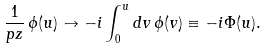Convert formula to latex. <formula><loc_0><loc_0><loc_500><loc_500>\frac { 1 } { p z } \, \phi ( u ) \to - i \int _ { 0 } ^ { u } d v \, \phi ( v ) \equiv - i \Phi ( u ) .</formula> 